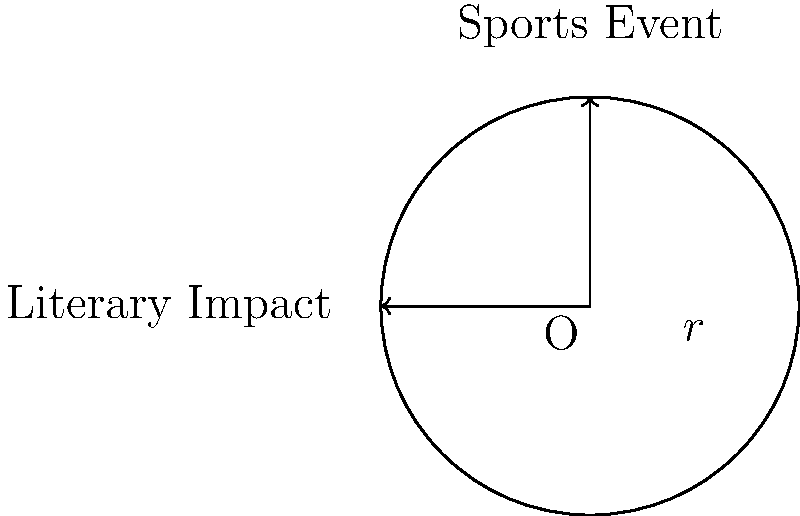A circular sports field has a radius of 50 meters. If the area of this field represents the momentary entertainment of a sports event, and the radius represents the lasting impact of a novel, how many times greater is the area of literary impact compared to the sports field, assuming the novel's impact extends to a radius of 200 meters? To solve this problem, we need to compare the areas of two circles: one representing the sports field and another representing the impact of literature.

Step 1: Calculate the area of the sports field
Area of a circle = $\pi r^2$
Sports field area = $\pi (50)^2 = 2500\pi$ square meters

Step 2: Calculate the area of literary impact
Literary impact area = $\pi (200)^2 = 40000\pi$ square meters

Step 3: Compare the two areas
Ratio = Literary impact area / Sports field area
      = $40000\pi / 2500\pi$
      = $40000 / 2500$
      = 16

Therefore, the area of literary impact is 16 times greater than the area of the sports field.

This comparison illustrates that while a sports event may occupy a significant physical space, the lasting impact of literature (represented by a much larger radius) covers a far greater metaphorical "area" in terms of its influence and long-term effects on society.
Answer: 16 times greater 